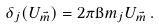Convert formula to latex. <formula><loc_0><loc_0><loc_500><loc_500>\delta _ { j } ( U _ { \vec { m } } ) = 2 \pi \i m _ { j } U _ { \vec { m } } \, .</formula> 